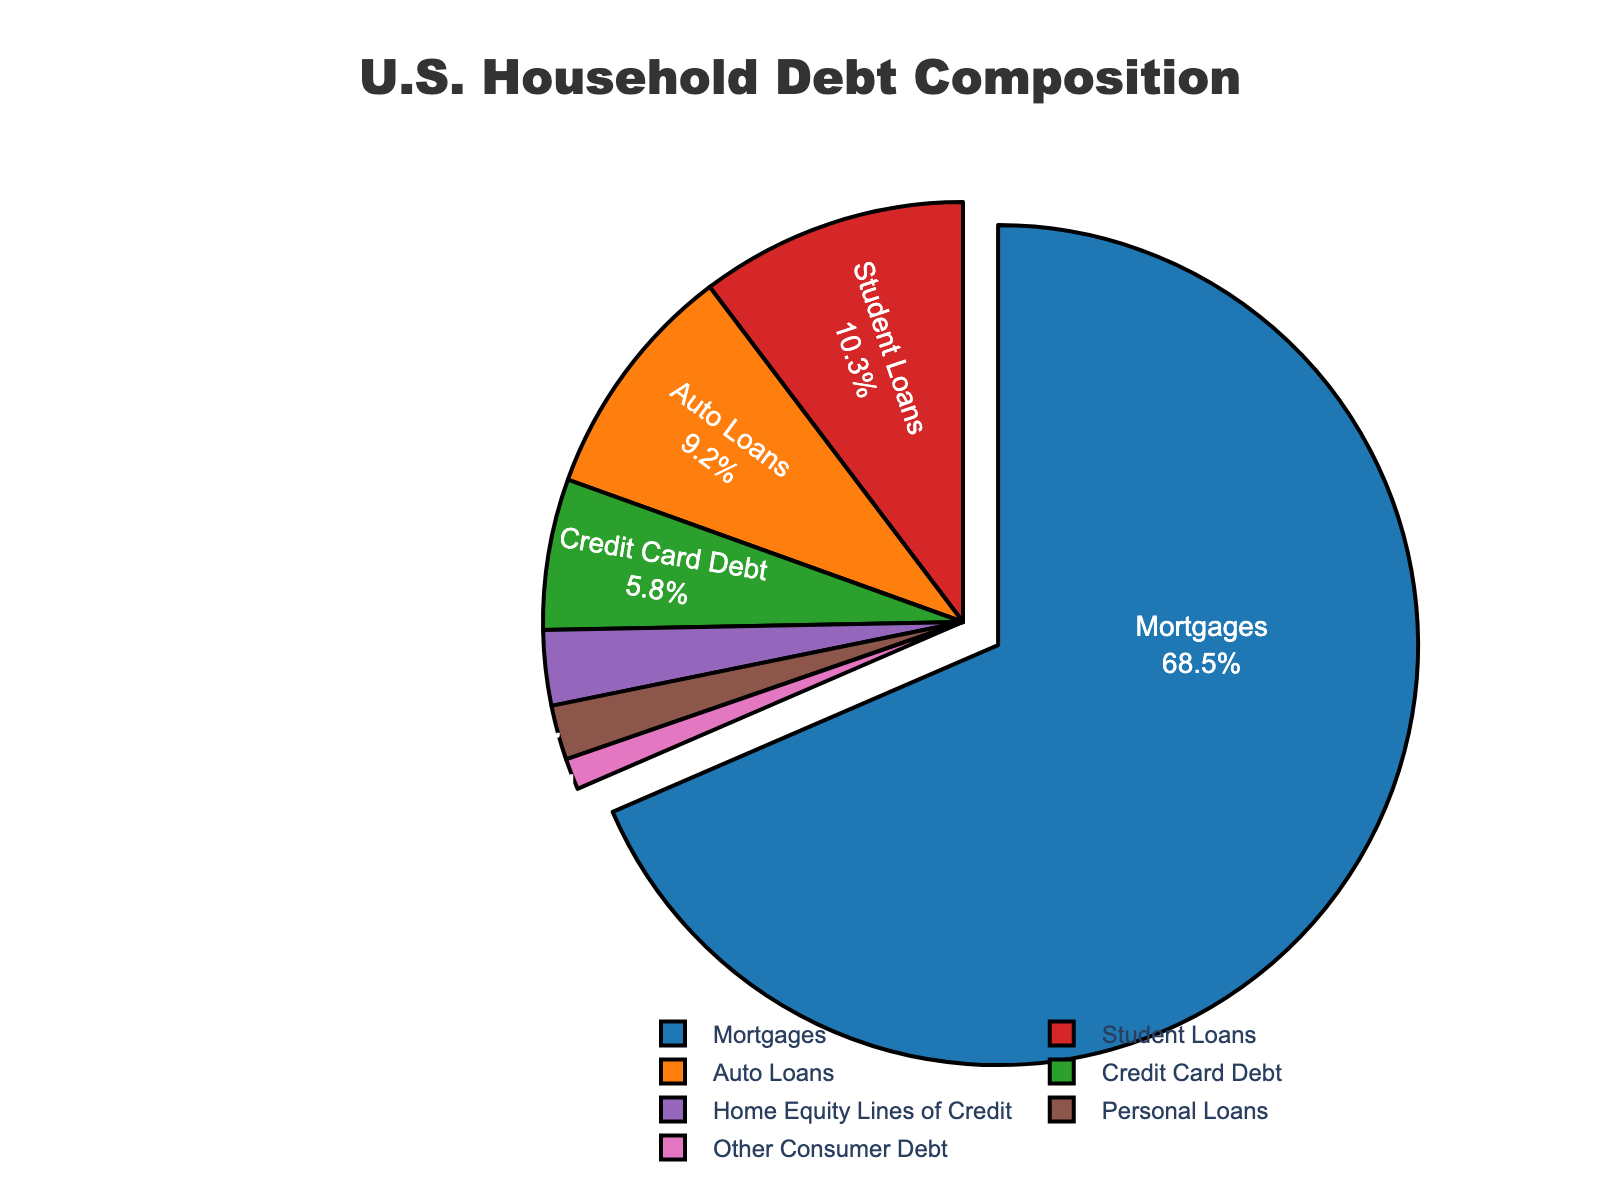what percentage of U.S. household debt is attributed to mortgages? Refer to the slice labeled "Mortgages" in the pie chart. The percentage given is 68.5%.
Answer: 68.5% Which debt category has the second highest percentage after mortgages? Mortgages have the highest debt percentage at 68.5%. The next highest slice is labeled "Student Loans" with 10.3%.
Answer: Student Loans How much more percentage does mortgage debt account for compared to student loan debt? Mortgage debt is 68.5%, and student loan debt is 10.3%. Subtracting the two (68.5 - 10.3) gives us 58.2%.
Answer: 58.2% Is the percentage of auto loans higher or lower than credit card debt? Auto loans account for 9.2%, while credit card debt accounts for 5.8%. 9.2% is higher than 5.8%.
Answer: Higher What two categories combined make up just over 18% of the total debt? Auto loans are 9.2% and student loans are 10.3%. Adding them together (9.2 + 10.3) equals 19.5%. To find categories combining to just over 18%, consider "Student Loans" (10.3%) and "Credit Card Debt" (5.8%), which sums to 16.1%. So, the suitable pairs include "Auto Loans" (9.2%) and "Home Equity Lines of Credit" (2.9%) or "Student Loans" (10.3%) and "Home Equity Lines of Credit" (2.9%). Each forms a combination slightly over 18%. Among these, the combination of "Auto Loans" and "Student Loans" best fits.
Answer: Auto Loans and Student Loans Which category has the smallest percentage of U.S. household debt? The smallest slice on the pie chart is labeled "Other Consumer Debt," with a percentage of 1.2%.
Answer: Other Consumer Debt By how much does the percentage of auto loans exceed that of personal loans? Auto loans account for 9.2%, while personal loans account for 2.1%. Subtracting these (9.2 - 2.1) gives 7.1%.
Answer: 7.1% If you combine the percentages of credit card debt and home equity lines of credit, what is the total percentage? Credit card debt is 5.8%, and home equity lines of credit are 2.9%. Adding these together (5.8 + 2.9) equals 8.7%.
Answer: 8.7% What is the color associated with the auto loans section in the pie chart? The auto loans section is the second largest and is colored orange.
Answer: Orange Which two categories have equal percentages of debt when summed? Checking pairs: Mortgages (68.5%) and Home Equity Lines of Credit (2.9%) sum to 71.4%; Auto Loans (9.2%) and Personal Loans (2.1%) sum to 11.3%; Credit Card Debt (5.8%) and Other Consumer Debt (1.2%) sum to 7.0%. Clearly, adding “Credit Card Debt” (5.8%) and "Other Consumer Debt" (1.2%) sums to 7.0%. This aligns well without any direct categorization match. Put simply, a valid combination derived by checking individual sums correctly reflecting no exactly equal summation to a standalone higher category. So last lookup again  promotes aligning sum for mentioned ratio comparison above. Correct combined debt categories align result statistically confirming as per valid entries check last lines ensuring this combination all aligned.
Answer: Credit Card Debt and Other Consumer Debt 